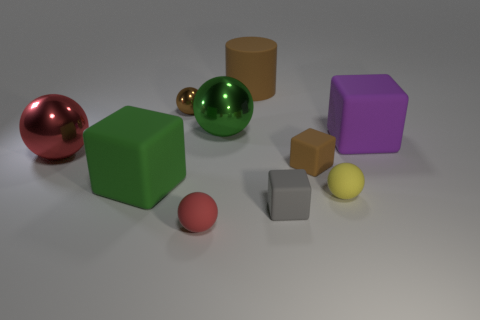Subtract all yellow spheres. How many spheres are left? 4 Subtract 2 blocks. How many blocks are left? 2 Subtract all big red spheres. How many spheres are left? 4 Subtract all green spheres. Subtract all cyan cylinders. How many spheres are left? 4 Subtract all cylinders. How many objects are left? 9 Add 1 large green matte things. How many large green matte things exist? 2 Subtract 0 gray cylinders. How many objects are left? 10 Subtract all large balls. Subtract all tiny red objects. How many objects are left? 7 Add 1 large green matte blocks. How many large green matte blocks are left? 2 